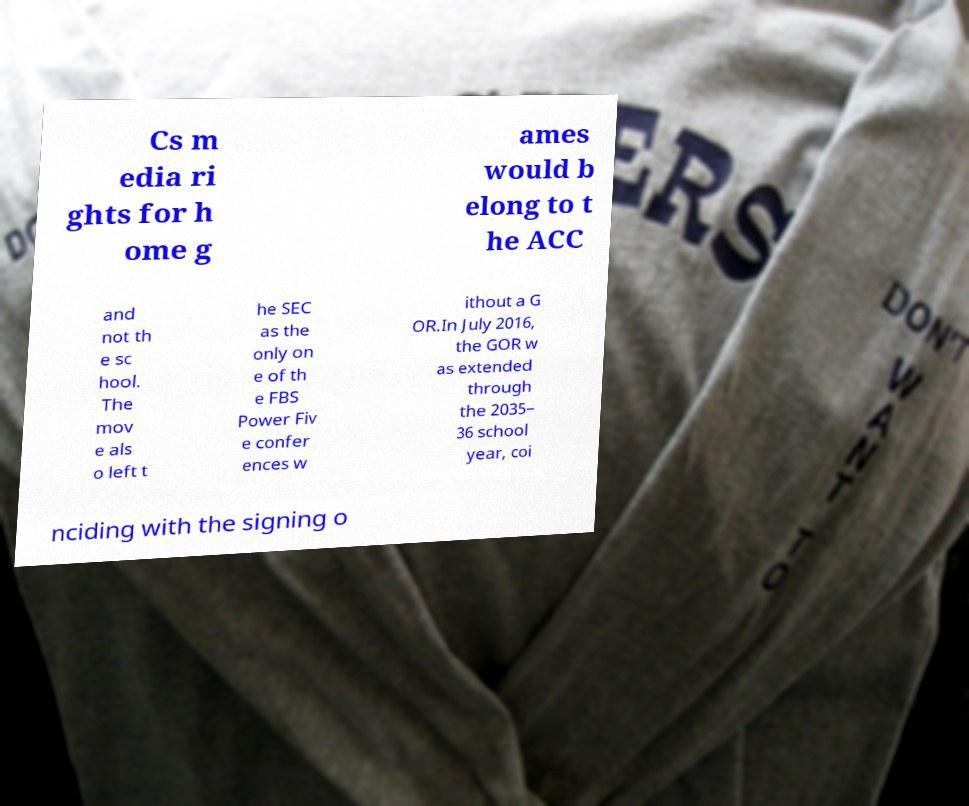Please identify and transcribe the text found in this image. Cs m edia ri ghts for h ome g ames would b elong to t he ACC and not th e sc hool. The mov e als o left t he SEC as the only on e of th e FBS Power Fiv e confer ences w ithout a G OR.In July 2016, the GOR w as extended through the 2035– 36 school year, coi nciding with the signing o 